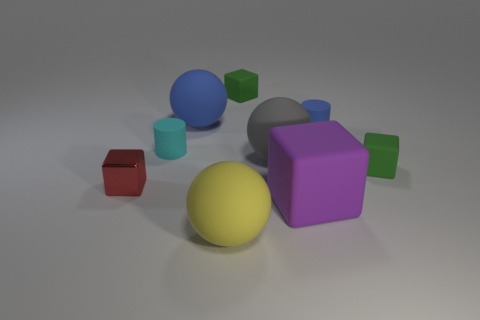Subtract all green blocks. How many were subtracted if there are1green blocks left? 1 Subtract 2 blocks. How many blocks are left? 2 Subtract all brown blocks. Subtract all yellow cylinders. How many blocks are left? 4 Subtract all balls. How many objects are left? 6 Subtract all tiny rubber cylinders. Subtract all small purple metal blocks. How many objects are left? 7 Add 3 big gray rubber objects. How many big gray rubber objects are left? 4 Add 1 gray things. How many gray things exist? 2 Subtract 1 gray spheres. How many objects are left? 8 